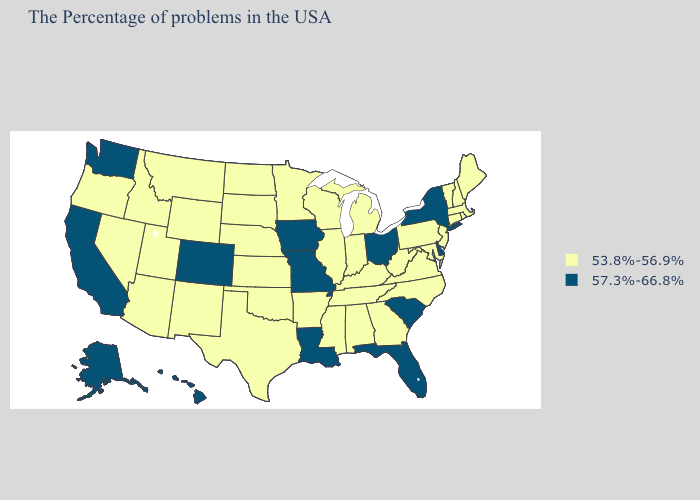How many symbols are there in the legend?
Keep it brief. 2. What is the highest value in the South ?
Keep it brief. 57.3%-66.8%. What is the highest value in states that border Vermont?
Keep it brief. 57.3%-66.8%. Name the states that have a value in the range 57.3%-66.8%?
Concise answer only. New York, Delaware, South Carolina, Ohio, Florida, Louisiana, Missouri, Iowa, Colorado, California, Washington, Alaska, Hawaii. Name the states that have a value in the range 53.8%-56.9%?
Give a very brief answer. Maine, Massachusetts, Rhode Island, New Hampshire, Vermont, Connecticut, New Jersey, Maryland, Pennsylvania, Virginia, North Carolina, West Virginia, Georgia, Michigan, Kentucky, Indiana, Alabama, Tennessee, Wisconsin, Illinois, Mississippi, Arkansas, Minnesota, Kansas, Nebraska, Oklahoma, Texas, South Dakota, North Dakota, Wyoming, New Mexico, Utah, Montana, Arizona, Idaho, Nevada, Oregon. What is the highest value in the USA?
Write a very short answer. 57.3%-66.8%. What is the value of Minnesota?
Concise answer only. 53.8%-56.9%. Name the states that have a value in the range 57.3%-66.8%?
Concise answer only. New York, Delaware, South Carolina, Ohio, Florida, Louisiana, Missouri, Iowa, Colorado, California, Washington, Alaska, Hawaii. What is the lowest value in the USA?
Write a very short answer. 53.8%-56.9%. What is the highest value in the USA?
Short answer required. 57.3%-66.8%. Name the states that have a value in the range 57.3%-66.8%?
Short answer required. New York, Delaware, South Carolina, Ohio, Florida, Louisiana, Missouri, Iowa, Colorado, California, Washington, Alaska, Hawaii. What is the value of Georgia?
Short answer required. 53.8%-56.9%. What is the value of Colorado?
Keep it brief. 57.3%-66.8%. What is the lowest value in the MidWest?
Concise answer only. 53.8%-56.9%. 